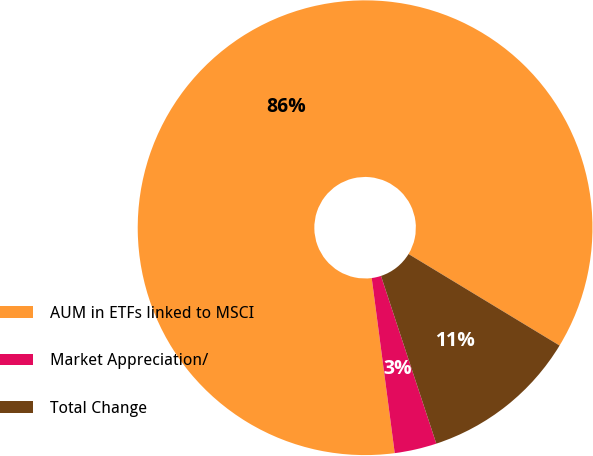<chart> <loc_0><loc_0><loc_500><loc_500><pie_chart><fcel>AUM in ETFs linked to MSCI<fcel>Market Appreciation/<fcel>Total Change<nl><fcel>85.75%<fcel>2.99%<fcel>11.26%<nl></chart> 